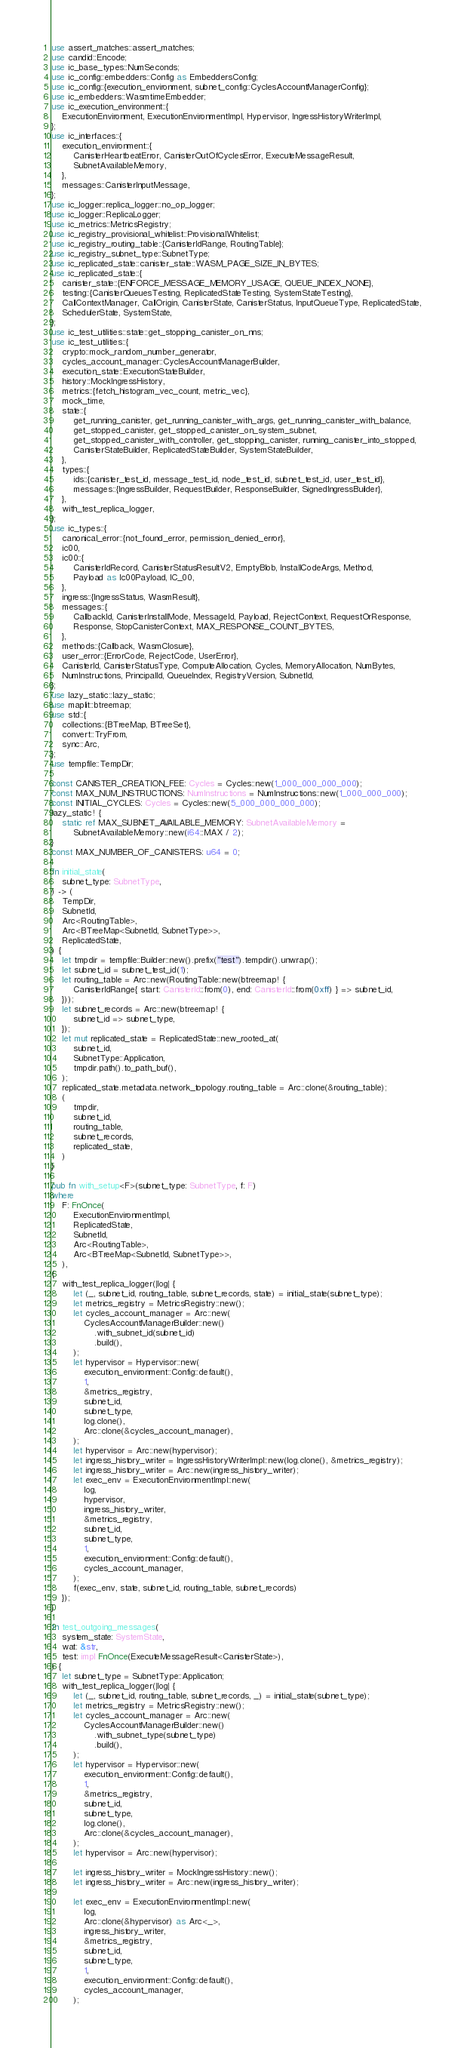<code> <loc_0><loc_0><loc_500><loc_500><_Rust_>use assert_matches::assert_matches;
use candid::Encode;
use ic_base_types::NumSeconds;
use ic_config::embedders::Config as EmbeddersConfig;
use ic_config::{execution_environment, subnet_config::CyclesAccountManagerConfig};
use ic_embedders::WasmtimeEmbedder;
use ic_execution_environment::{
    ExecutionEnvironment, ExecutionEnvironmentImpl, Hypervisor, IngressHistoryWriterImpl,
};
use ic_interfaces::{
    execution_environment::{
        CanisterHeartbeatError, CanisterOutOfCyclesError, ExecuteMessageResult,
        SubnetAvailableMemory,
    },
    messages::CanisterInputMessage,
};
use ic_logger::replica_logger::no_op_logger;
use ic_logger::ReplicaLogger;
use ic_metrics::MetricsRegistry;
use ic_registry_provisional_whitelist::ProvisionalWhitelist;
use ic_registry_routing_table::{CanisterIdRange, RoutingTable};
use ic_registry_subnet_type::SubnetType;
use ic_replicated_state::canister_state::WASM_PAGE_SIZE_IN_BYTES;
use ic_replicated_state::{
    canister_state::{ENFORCE_MESSAGE_MEMORY_USAGE, QUEUE_INDEX_NONE},
    testing::{CanisterQueuesTesting, ReplicatedStateTesting, SystemStateTesting},
    CallContextManager, CallOrigin, CanisterState, CanisterStatus, InputQueueType, ReplicatedState,
    SchedulerState, SystemState,
};
use ic_test_utilities::state::get_stopping_canister_on_nns;
use ic_test_utilities::{
    crypto::mock_random_number_generator,
    cycles_account_manager::CyclesAccountManagerBuilder,
    execution_state::ExecutionStateBuilder,
    history::MockIngressHistory,
    metrics::{fetch_histogram_vec_count, metric_vec},
    mock_time,
    state::{
        get_running_canister, get_running_canister_with_args, get_running_canister_with_balance,
        get_stopped_canister, get_stopped_canister_on_system_subnet,
        get_stopped_canister_with_controller, get_stopping_canister, running_canister_into_stopped,
        CanisterStateBuilder, ReplicatedStateBuilder, SystemStateBuilder,
    },
    types::{
        ids::{canister_test_id, message_test_id, node_test_id, subnet_test_id, user_test_id},
        messages::{IngressBuilder, RequestBuilder, ResponseBuilder, SignedIngressBuilder},
    },
    with_test_replica_logger,
};
use ic_types::{
    canonical_error::{not_found_error, permission_denied_error},
    ic00,
    ic00::{
        CanisterIdRecord, CanisterStatusResultV2, EmptyBlob, InstallCodeArgs, Method,
        Payload as Ic00Payload, IC_00,
    },
    ingress::{IngressStatus, WasmResult},
    messages::{
        CallbackId, CanisterInstallMode, MessageId, Payload, RejectContext, RequestOrResponse,
        Response, StopCanisterContext, MAX_RESPONSE_COUNT_BYTES,
    },
    methods::{Callback, WasmClosure},
    user_error::{ErrorCode, RejectCode, UserError},
    CanisterId, CanisterStatusType, ComputeAllocation, Cycles, MemoryAllocation, NumBytes,
    NumInstructions, PrincipalId, QueueIndex, RegistryVersion, SubnetId,
};
use lazy_static::lazy_static;
use maplit::btreemap;
use std::{
    collections::{BTreeMap, BTreeSet},
    convert::TryFrom,
    sync::Arc,
};
use tempfile::TempDir;

const CANISTER_CREATION_FEE: Cycles = Cycles::new(1_000_000_000_000);
const MAX_NUM_INSTRUCTIONS: NumInstructions = NumInstructions::new(1_000_000_000);
const INITIAL_CYCLES: Cycles = Cycles::new(5_000_000_000_000);
lazy_static! {
    static ref MAX_SUBNET_AVAILABLE_MEMORY: SubnetAvailableMemory =
        SubnetAvailableMemory::new(i64::MAX / 2);
}
const MAX_NUMBER_OF_CANISTERS: u64 = 0;

fn initial_state(
    subnet_type: SubnetType,
) -> (
    TempDir,
    SubnetId,
    Arc<RoutingTable>,
    Arc<BTreeMap<SubnetId, SubnetType>>,
    ReplicatedState,
) {
    let tmpdir = tempfile::Builder::new().prefix("test").tempdir().unwrap();
    let subnet_id = subnet_test_id(1);
    let routing_table = Arc::new(RoutingTable::new(btreemap! {
        CanisterIdRange{ start: CanisterId::from(0), end: CanisterId::from(0xff) } => subnet_id,
    }));
    let subnet_records = Arc::new(btreemap! {
        subnet_id => subnet_type,
    });
    let mut replicated_state = ReplicatedState::new_rooted_at(
        subnet_id,
        SubnetType::Application,
        tmpdir.path().to_path_buf(),
    );
    replicated_state.metadata.network_topology.routing_table = Arc::clone(&routing_table);
    (
        tmpdir,
        subnet_id,
        routing_table,
        subnet_records,
        replicated_state,
    )
}

pub fn with_setup<F>(subnet_type: SubnetType, f: F)
where
    F: FnOnce(
        ExecutionEnvironmentImpl,
        ReplicatedState,
        SubnetId,
        Arc<RoutingTable>,
        Arc<BTreeMap<SubnetId, SubnetType>>,
    ),
{
    with_test_replica_logger(|log| {
        let (_, subnet_id, routing_table, subnet_records, state) = initial_state(subnet_type);
        let metrics_registry = MetricsRegistry::new();
        let cycles_account_manager = Arc::new(
            CyclesAccountManagerBuilder::new()
                .with_subnet_id(subnet_id)
                .build(),
        );
        let hypervisor = Hypervisor::new(
            execution_environment::Config::default(),
            1,
            &metrics_registry,
            subnet_id,
            subnet_type,
            log.clone(),
            Arc::clone(&cycles_account_manager),
        );
        let hypervisor = Arc::new(hypervisor);
        let ingress_history_writer = IngressHistoryWriterImpl::new(log.clone(), &metrics_registry);
        let ingress_history_writer = Arc::new(ingress_history_writer);
        let exec_env = ExecutionEnvironmentImpl::new(
            log,
            hypervisor,
            ingress_history_writer,
            &metrics_registry,
            subnet_id,
            subnet_type,
            1,
            execution_environment::Config::default(),
            cycles_account_manager,
        );
        f(exec_env, state, subnet_id, routing_table, subnet_records)
    });
}

fn test_outgoing_messages(
    system_state: SystemState,
    wat: &str,
    test: impl FnOnce(ExecuteMessageResult<CanisterState>),
) {
    let subnet_type = SubnetType::Application;
    with_test_replica_logger(|log| {
        let (_, subnet_id, routing_table, subnet_records, _) = initial_state(subnet_type);
        let metrics_registry = MetricsRegistry::new();
        let cycles_account_manager = Arc::new(
            CyclesAccountManagerBuilder::new()
                .with_subnet_type(subnet_type)
                .build(),
        );
        let hypervisor = Hypervisor::new(
            execution_environment::Config::default(),
            1,
            &metrics_registry,
            subnet_id,
            subnet_type,
            log.clone(),
            Arc::clone(&cycles_account_manager),
        );
        let hypervisor = Arc::new(hypervisor);

        let ingress_history_writer = MockIngressHistory::new();
        let ingress_history_writer = Arc::new(ingress_history_writer);

        let exec_env = ExecutionEnvironmentImpl::new(
            log,
            Arc::clone(&hypervisor) as Arc<_>,
            ingress_history_writer,
            &metrics_registry,
            subnet_id,
            subnet_type,
            1,
            execution_environment::Config::default(),
            cycles_account_manager,
        );</code> 